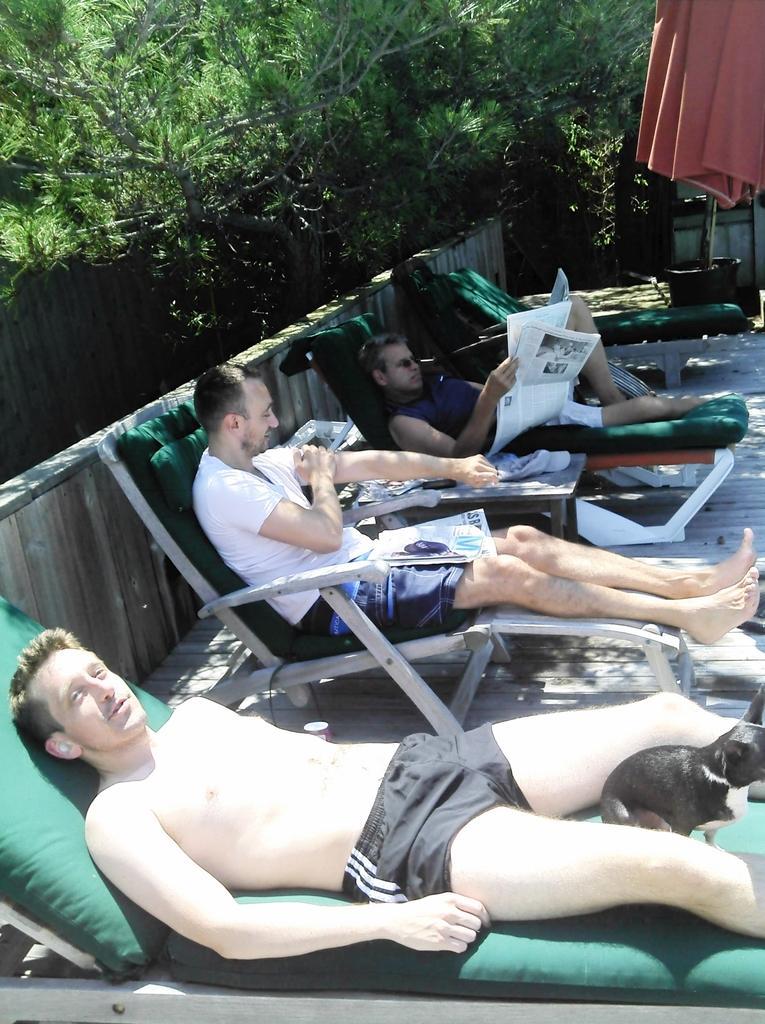In one or two sentences, can you explain what this image depicts? This image consists of three persons sitting in the beach chairs. To the left, there is a railing made up of wood. In the background, there are trees. To the right top, there is a towel in red color. In the front, there is a cat sitting on the chair. At the bottom, there is a floor. 